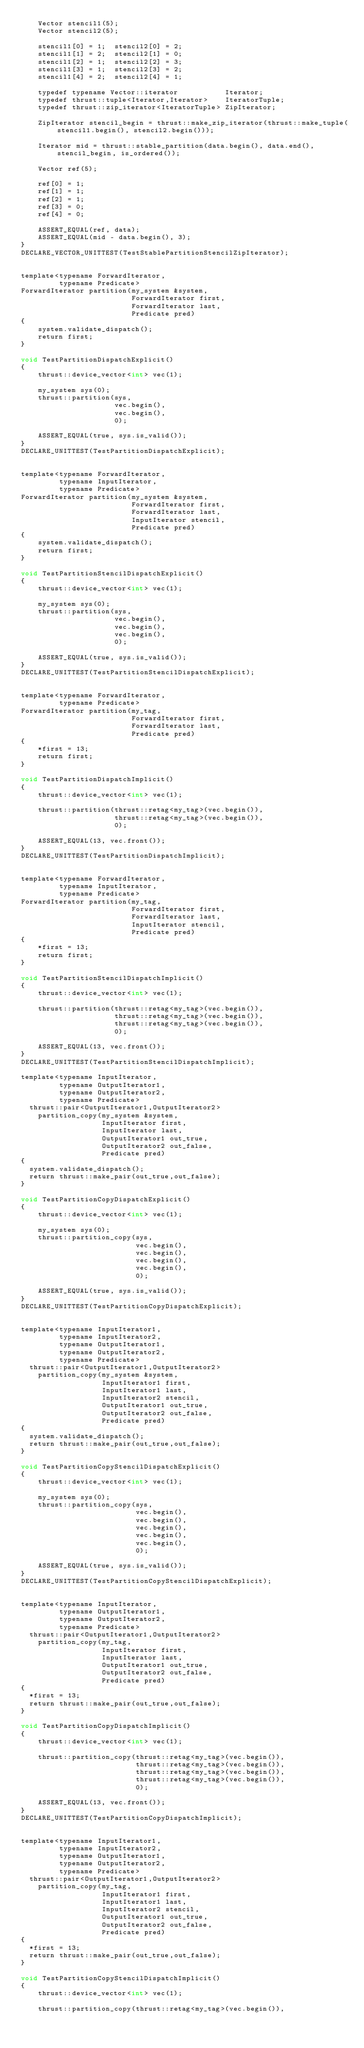Convert code to text. <code><loc_0><loc_0><loc_500><loc_500><_Cuda_>    Vector stencil1(5);
    Vector stencil2(5);

    stencil1[0] = 1;  stencil2[0] = 2; 
    stencil1[1] = 2;  stencil2[1] = 0;
    stencil1[2] = 1;  stencil2[2] = 3;
    stencil1[3] = 1;  stencil2[3] = 2;
    stencil1[4] = 2;  stencil2[4] = 1;

    typedef typename Vector::iterator           Iterator;
    typedef thrust::tuple<Iterator,Iterator>    IteratorTuple;
    typedef thrust::zip_iterator<IteratorTuple> ZipIterator;

    ZipIterator stencil_begin = thrust::make_zip_iterator(thrust::make_tuple(stencil1.begin(), stencil2.begin()));

    Iterator mid = thrust::stable_partition(data.begin(), data.end(), stencil_begin, is_ordered());

    Vector ref(5);

    ref[0] = 1;
    ref[1] = 1;
    ref[2] = 1;
    ref[3] = 0;
    ref[4] = 0;

    ASSERT_EQUAL(ref, data);
    ASSERT_EQUAL(mid - data.begin(), 3);
}
DECLARE_VECTOR_UNITTEST(TestStablePartitionStencilZipIterator);


template<typename ForwardIterator,
         typename Predicate>
ForwardIterator partition(my_system &system,
                          ForwardIterator first,
                          ForwardIterator last,
                          Predicate pred)
{
    system.validate_dispatch();
    return first;
}

void TestPartitionDispatchExplicit()
{
    thrust::device_vector<int> vec(1);

    my_system sys(0);
    thrust::partition(sys,
                      vec.begin(),
                      vec.begin(),
                      0);

    ASSERT_EQUAL(true, sys.is_valid());
}
DECLARE_UNITTEST(TestPartitionDispatchExplicit);


template<typename ForwardIterator,
         typename InputIterator,
         typename Predicate>
ForwardIterator partition(my_system &system,
                          ForwardIterator first,
                          ForwardIterator last,
                          InputIterator stencil,
                          Predicate pred)
{
    system.validate_dispatch();
    return first;
}

void TestPartitionStencilDispatchExplicit()
{
    thrust::device_vector<int> vec(1);

    my_system sys(0);
    thrust::partition(sys,
                      vec.begin(),
                      vec.begin(),
                      vec.begin(),
                      0);

    ASSERT_EQUAL(true, sys.is_valid());
}
DECLARE_UNITTEST(TestPartitionStencilDispatchExplicit);


template<typename ForwardIterator,
         typename Predicate>
ForwardIterator partition(my_tag,
                          ForwardIterator first,
                          ForwardIterator last,
                          Predicate pred)
{
    *first = 13;
    return first;
}

void TestPartitionDispatchImplicit()
{
    thrust::device_vector<int> vec(1);

    thrust::partition(thrust::retag<my_tag>(vec.begin()),
                      thrust::retag<my_tag>(vec.begin()),
                      0);

    ASSERT_EQUAL(13, vec.front());
}
DECLARE_UNITTEST(TestPartitionDispatchImplicit);


template<typename ForwardIterator,
         typename InputIterator,
         typename Predicate>
ForwardIterator partition(my_tag,
                          ForwardIterator first,
                          ForwardIterator last,
                          InputIterator stencil,
                          Predicate pred)
{
    *first = 13;
    return first;
}

void TestPartitionStencilDispatchImplicit()
{
    thrust::device_vector<int> vec(1);

    thrust::partition(thrust::retag<my_tag>(vec.begin()),
                      thrust::retag<my_tag>(vec.begin()),
                      thrust::retag<my_tag>(vec.begin()),
                      0);

    ASSERT_EQUAL(13, vec.front());
}
DECLARE_UNITTEST(TestPartitionStencilDispatchImplicit);

template<typename InputIterator,
         typename OutputIterator1,
         typename OutputIterator2,
         typename Predicate>
  thrust::pair<OutputIterator1,OutputIterator2>
    partition_copy(my_system &system,
                   InputIterator first,
                   InputIterator last,
                   OutputIterator1 out_true,
                   OutputIterator2 out_false,
                   Predicate pred)
{
  system.validate_dispatch();
  return thrust::make_pair(out_true,out_false);
}

void TestPartitionCopyDispatchExplicit()
{
    thrust::device_vector<int> vec(1);

    my_system sys(0);
    thrust::partition_copy(sys,
                           vec.begin(),
                           vec.begin(),
                           vec.begin(),
                           vec.begin(),
                           0);

    ASSERT_EQUAL(true, sys.is_valid());
}
DECLARE_UNITTEST(TestPartitionCopyDispatchExplicit);


template<typename InputIterator1,
         typename InputIterator2,
         typename OutputIterator1,
         typename OutputIterator2,
         typename Predicate>
  thrust::pair<OutputIterator1,OutputIterator2>
    partition_copy(my_system &system,
                   InputIterator1 first,
                   InputIterator1 last,
                   InputIterator2 stencil,
                   OutputIterator1 out_true,
                   OutputIterator2 out_false,
                   Predicate pred)
{
  system.validate_dispatch();
  return thrust::make_pair(out_true,out_false);
}

void TestPartitionCopyStencilDispatchExplicit()
{
    thrust::device_vector<int> vec(1);

    my_system sys(0);
    thrust::partition_copy(sys,
                           vec.begin(),
                           vec.begin(),
                           vec.begin(),
                           vec.begin(),
                           vec.begin(),
                           0);

    ASSERT_EQUAL(true, sys.is_valid());
}
DECLARE_UNITTEST(TestPartitionCopyStencilDispatchExplicit);


template<typename InputIterator,
         typename OutputIterator1,
         typename OutputIterator2,
         typename Predicate>
  thrust::pair<OutputIterator1,OutputIterator2>
    partition_copy(my_tag,
                   InputIterator first,
                   InputIterator last,
                   OutputIterator1 out_true,
                   OutputIterator2 out_false,
                   Predicate pred)
{
  *first = 13;
  return thrust::make_pair(out_true,out_false);
}

void TestPartitionCopyDispatchImplicit()
{
    thrust::device_vector<int> vec(1);

    thrust::partition_copy(thrust::retag<my_tag>(vec.begin()),
                           thrust::retag<my_tag>(vec.begin()),
                           thrust::retag<my_tag>(vec.begin()),
                           thrust::retag<my_tag>(vec.begin()),
                           0);

    ASSERT_EQUAL(13, vec.front());
}
DECLARE_UNITTEST(TestPartitionCopyDispatchImplicit);


template<typename InputIterator1,
         typename InputIterator2,
         typename OutputIterator1,
         typename OutputIterator2,
         typename Predicate>
  thrust::pair<OutputIterator1,OutputIterator2>
    partition_copy(my_tag,
                   InputIterator1 first,
                   InputIterator1 last,
                   InputIterator2 stencil,
                   OutputIterator1 out_true,
                   OutputIterator2 out_false,
                   Predicate pred)
{
  *first = 13;
  return thrust::make_pair(out_true,out_false);
}

void TestPartitionCopyStencilDispatchImplicit()
{
    thrust::device_vector<int> vec(1);

    thrust::partition_copy(thrust::retag<my_tag>(vec.begin()),</code> 